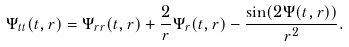Convert formula to latex. <formula><loc_0><loc_0><loc_500><loc_500>\Psi _ { t t } ( t , r ) = \Psi _ { r r } ( t , r ) + \frac { 2 } { r } \Psi _ { r } ( t , r ) - \frac { \sin ( 2 \Psi ( t , r ) ) } { r ^ { 2 } } .</formula> 